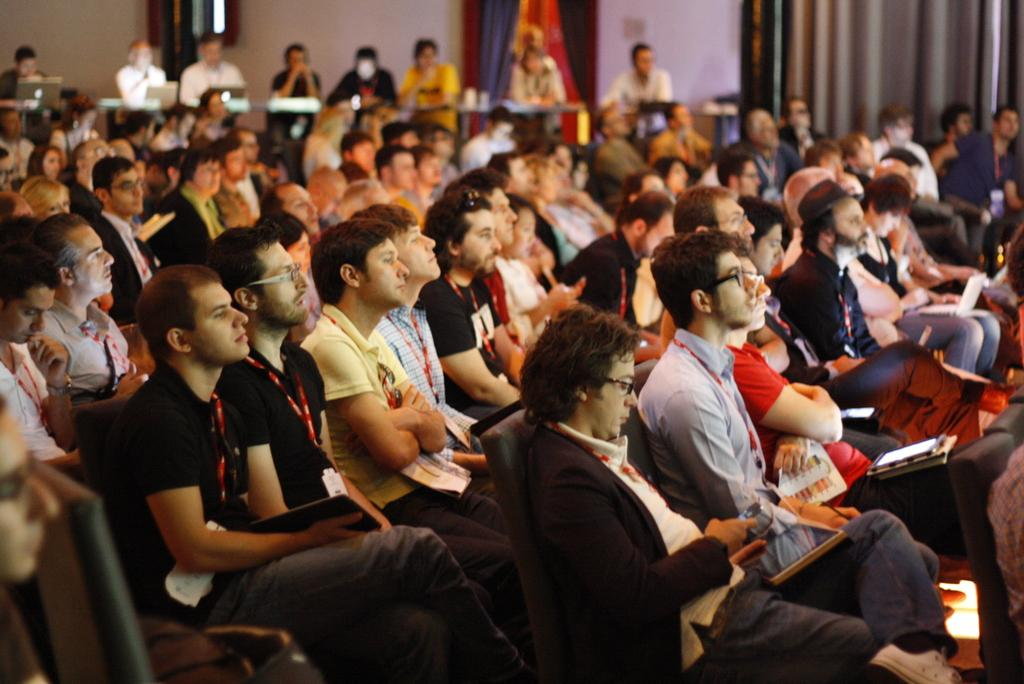How many individuals are present in the image? There are many people in the image. What are the people doing in the image? The people are sitting on chairs. What are the people looking at in the image? The people are looking at something. What type of songs are the people singing in the image? There is no indication in the image that the people are singing songs, so it cannot be determined from the picture. 